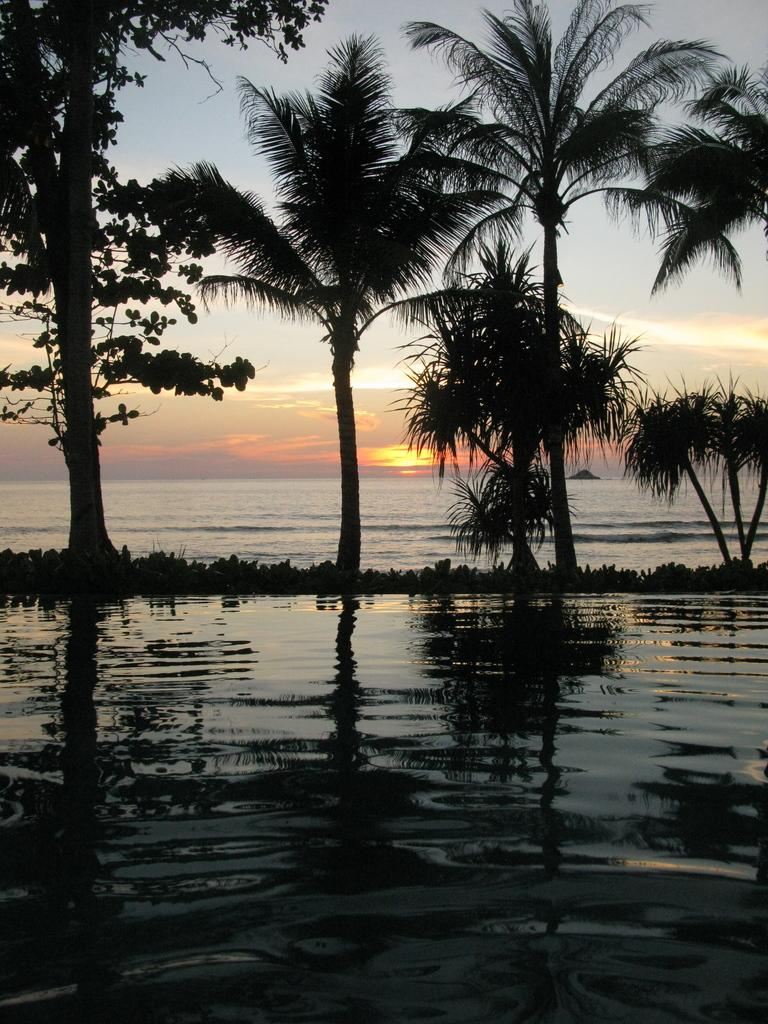What is the primary element visible in the image? There is water in the image. What other natural elements can be seen in the image? There are plants and trees visible in the image. What is visible in the background of the image? The sun and the sky are visible in the background of the image. What type of lead is being used to create the plants in the image? There is no indication in the image that the plants are created using lead or any other artificial material. 